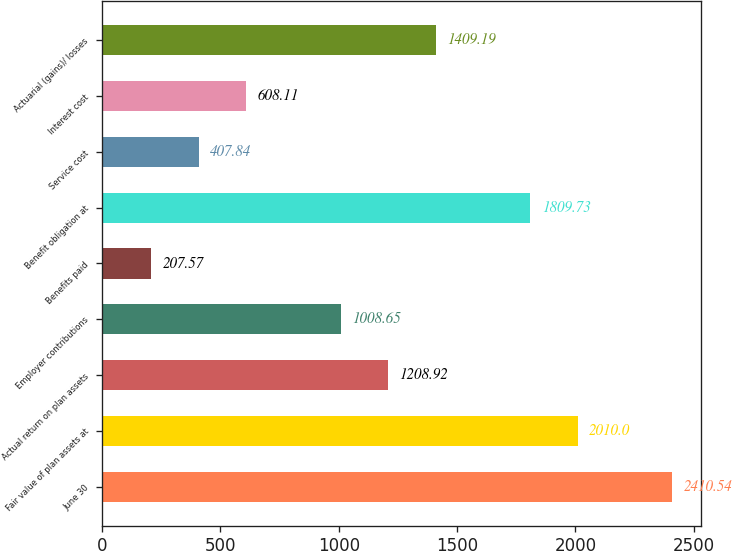Convert chart to OTSL. <chart><loc_0><loc_0><loc_500><loc_500><bar_chart><fcel>June 30<fcel>Fair value of plan assets at<fcel>Actual return on plan assets<fcel>Employer contributions<fcel>Benefits paid<fcel>Benefit obligation at<fcel>Service cost<fcel>Interest cost<fcel>Actuarial (gains)/ losses<nl><fcel>2410.54<fcel>2010<fcel>1208.92<fcel>1008.65<fcel>207.57<fcel>1809.73<fcel>407.84<fcel>608.11<fcel>1409.19<nl></chart> 